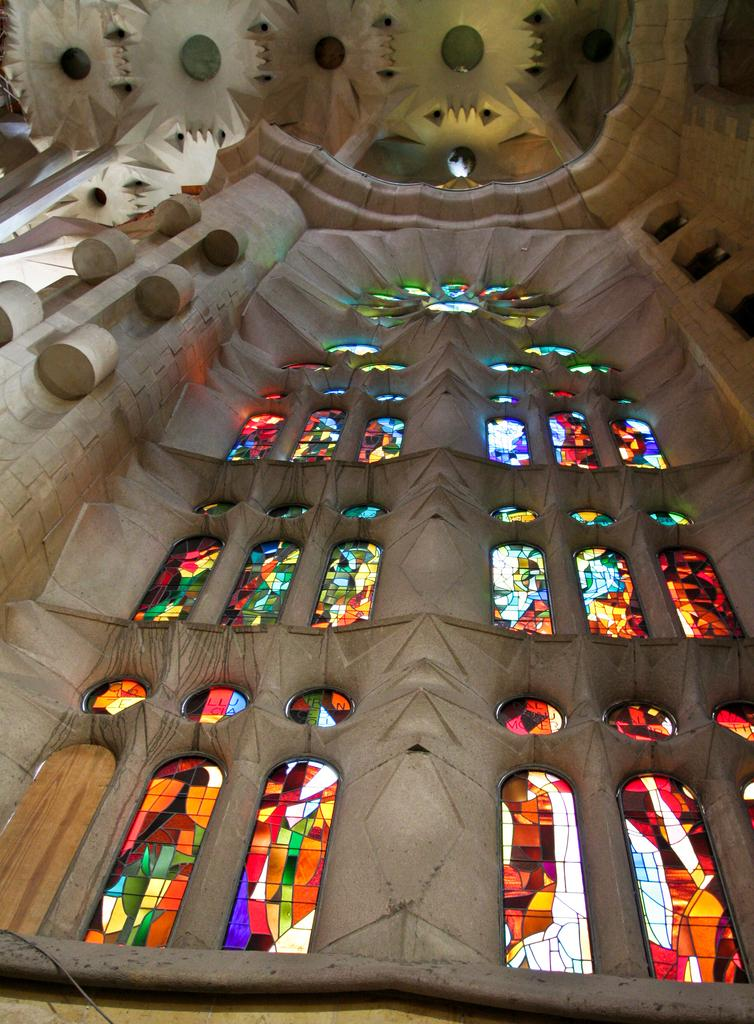What type of wall is featured in the image? The image contains a design wall. What can be seen on the design wall? There are windows visible on the design wall. What is unique about the windows on the design wall? The top of the windows has a colorful design. What else can be seen in the image related to the design wall? The design roof is visible in the image. What type of meal is being prepared on the design wall in the image? There is no meal preparation visible in the image; it features a design wall with windows and a colorful design on top. 